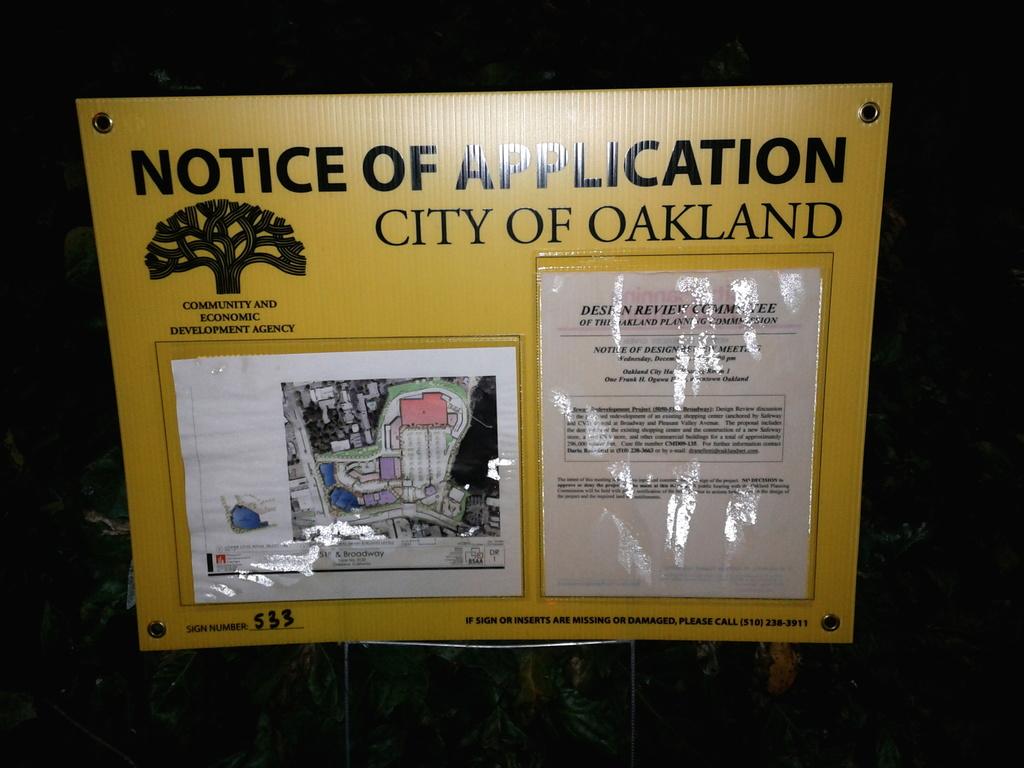What is the name of the city on the sign?
Provide a succinct answer. Oakland. What kind of notice is this?
Provide a short and direct response. Application. 